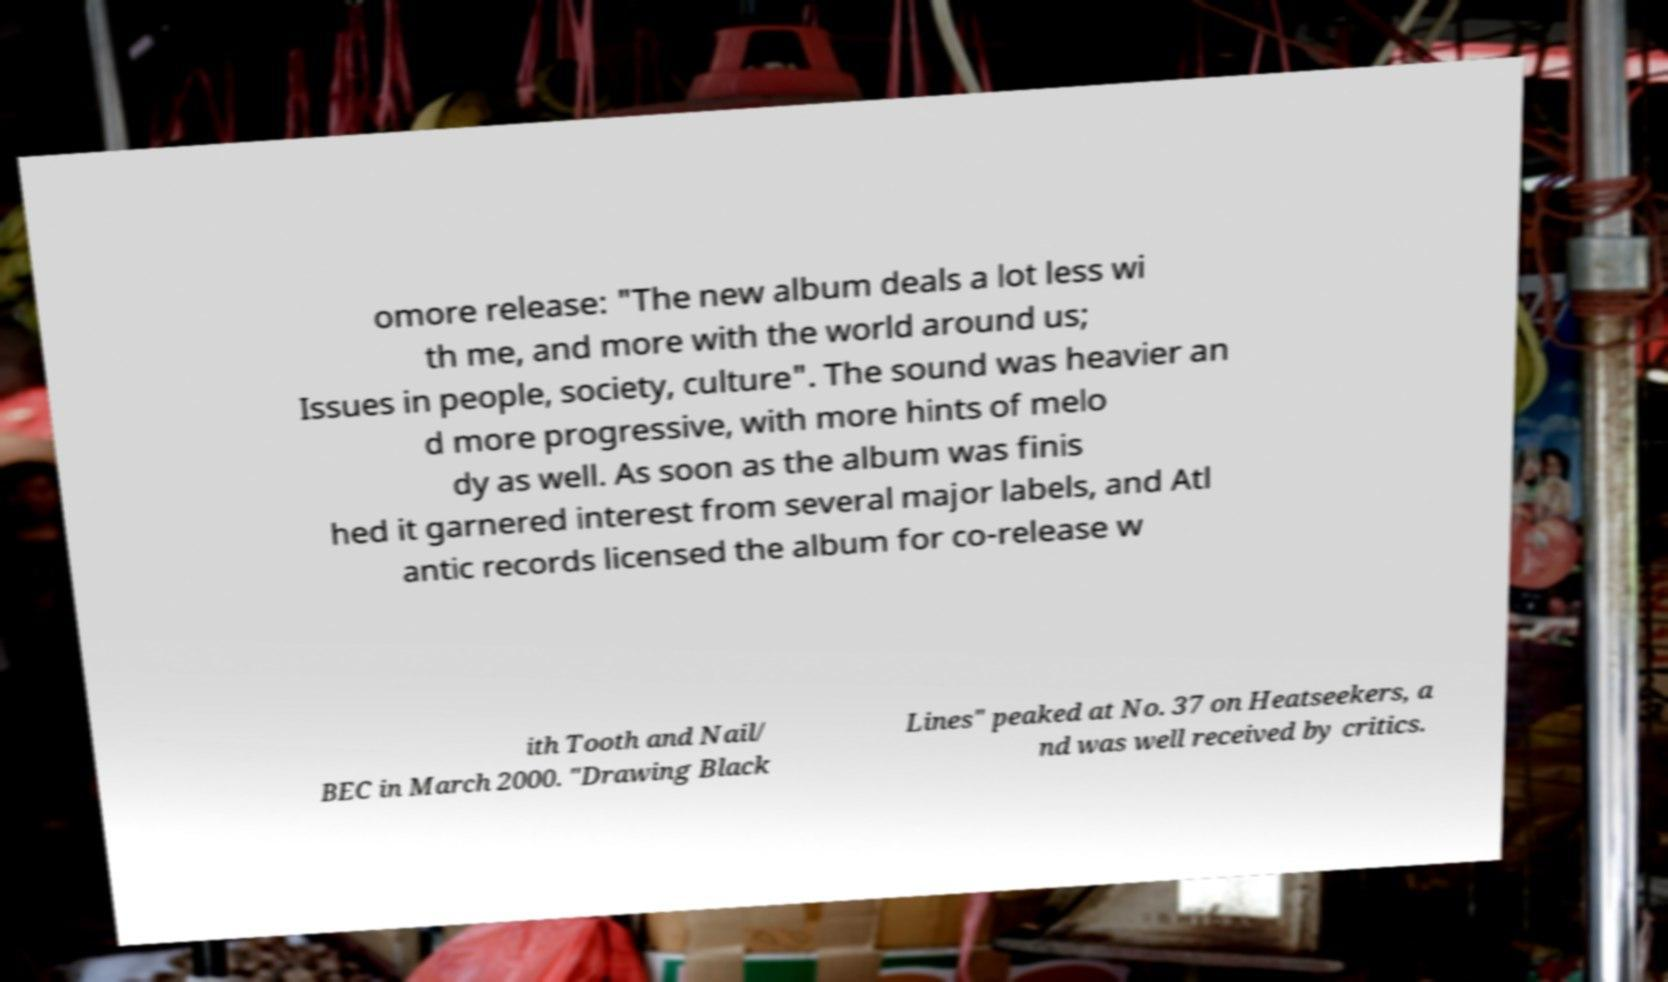Could you extract and type out the text from this image? omore release: "The new album deals a lot less wi th me, and more with the world around us; Issues in people, society, culture". The sound was heavier an d more progressive, with more hints of melo dy as well. As soon as the album was finis hed it garnered interest from several major labels, and Atl antic records licensed the album for co-release w ith Tooth and Nail/ BEC in March 2000. "Drawing Black Lines" peaked at No. 37 on Heatseekers, a nd was well received by critics. 